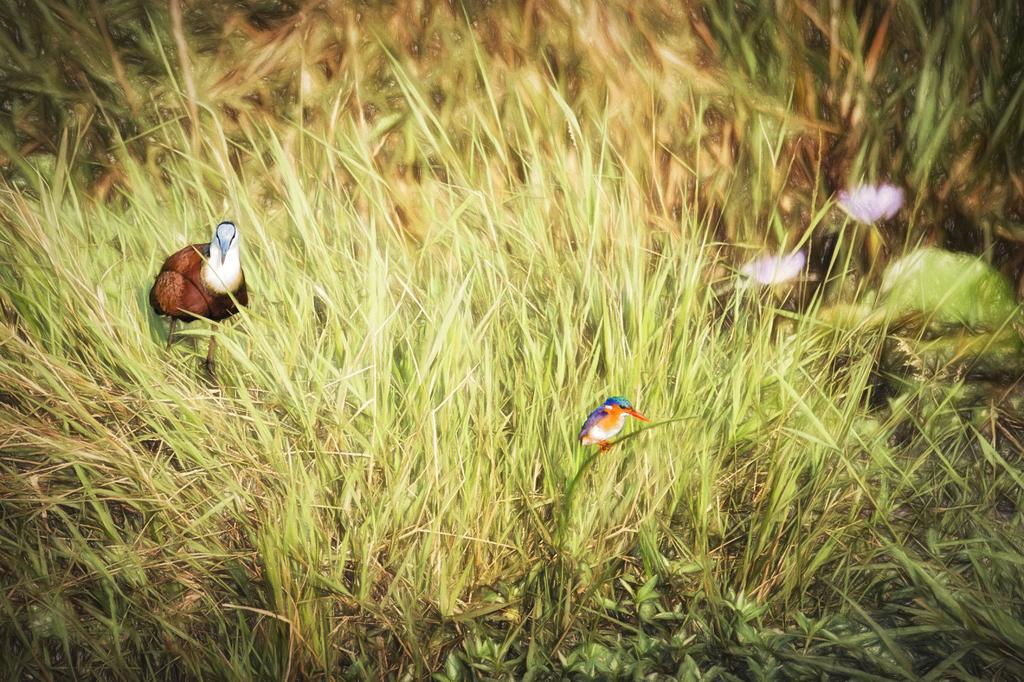What type of artwork is depicted in the image? The image is a painting. What type of natural environment can be seen in the painting? There is grass in the image. What type of animals are present in the painting? There are birds in the image. What color are the flowers in the painting? There are flowers in pink color in the image. How does the artist control the board while painting the image? The artist does not control a board while painting the image; the image is a painting, not a painting on a board. What type of nut can be seen in the image? There is no nut present in the image. 